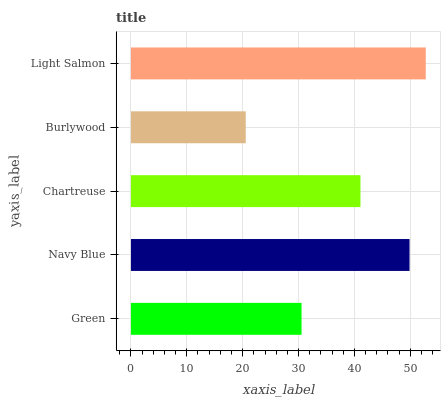Is Burlywood the minimum?
Answer yes or no. Yes. Is Light Salmon the maximum?
Answer yes or no. Yes. Is Navy Blue the minimum?
Answer yes or no. No. Is Navy Blue the maximum?
Answer yes or no. No. Is Navy Blue greater than Green?
Answer yes or no. Yes. Is Green less than Navy Blue?
Answer yes or no. Yes. Is Green greater than Navy Blue?
Answer yes or no. No. Is Navy Blue less than Green?
Answer yes or no. No. Is Chartreuse the high median?
Answer yes or no. Yes. Is Chartreuse the low median?
Answer yes or no. Yes. Is Navy Blue the high median?
Answer yes or no. No. Is Navy Blue the low median?
Answer yes or no. No. 